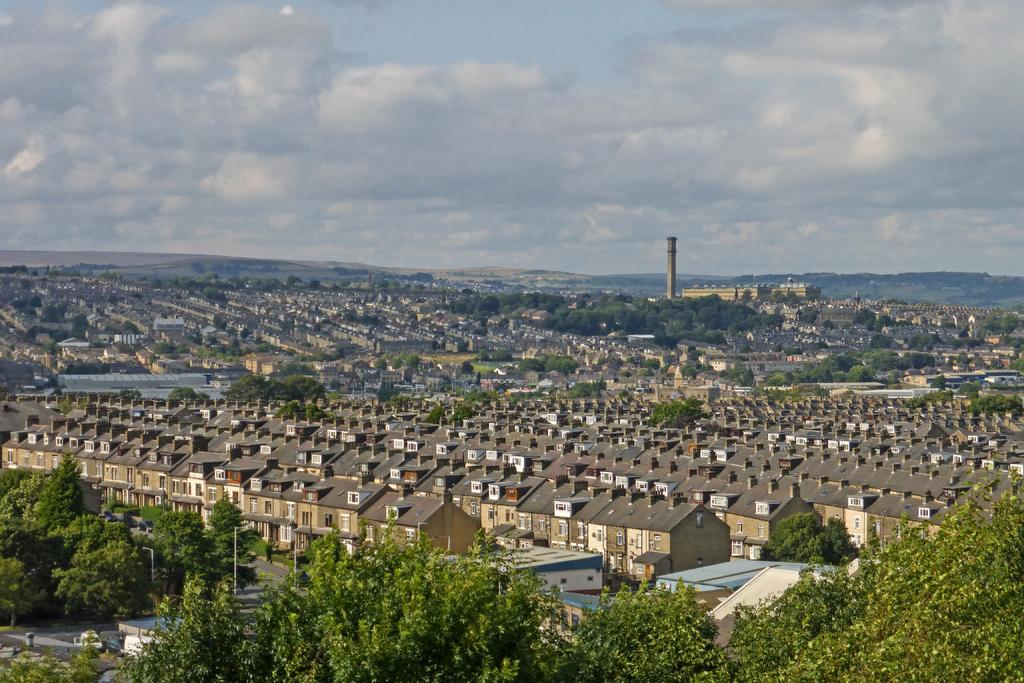What type of natural elements can be seen in the image? There are trees in the image. What type of man-made structures are present in the image? There are houses in the image. What can be seen in the distance in the image? There are mountains in the background of the image. What is the condition of the sky in the image? The sky is cloudy in the background of the image. Can you see any teeth or scissors in the image? There are no teeth or scissors present in the image. What activity are the trees participating in within the image? Trees are not capable of participating in activities, as they are inanimate objects. 